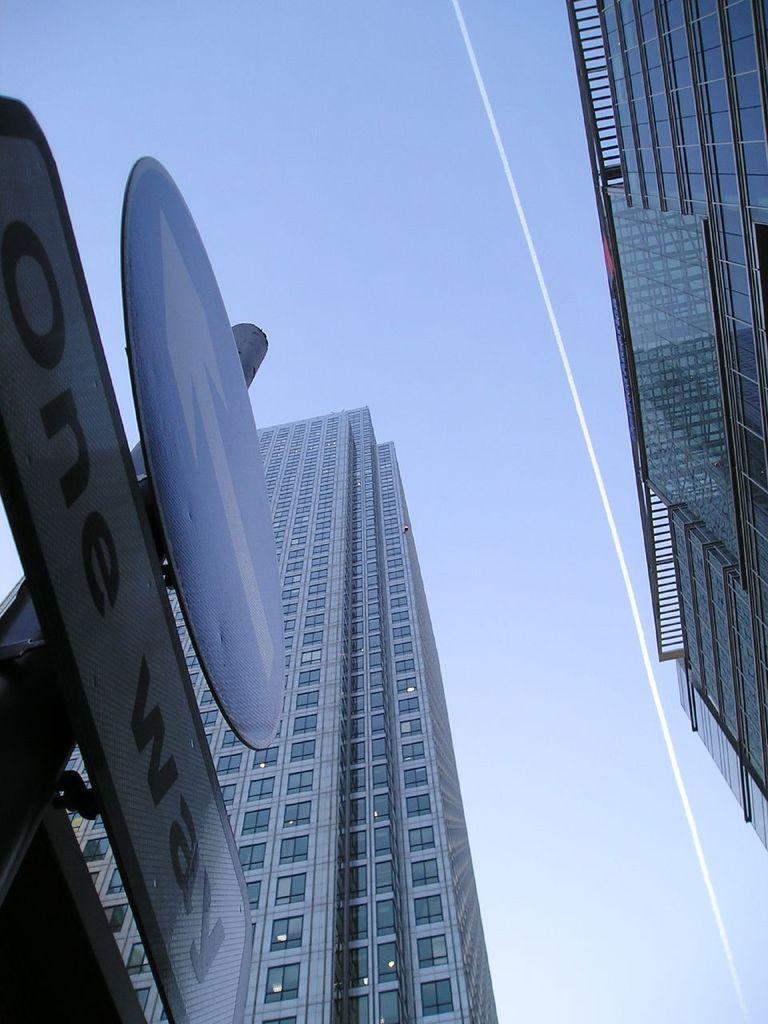Describe this image in one or two sentences. Sky is in blue color. Here we can see buildings, glass windows and signboards. 